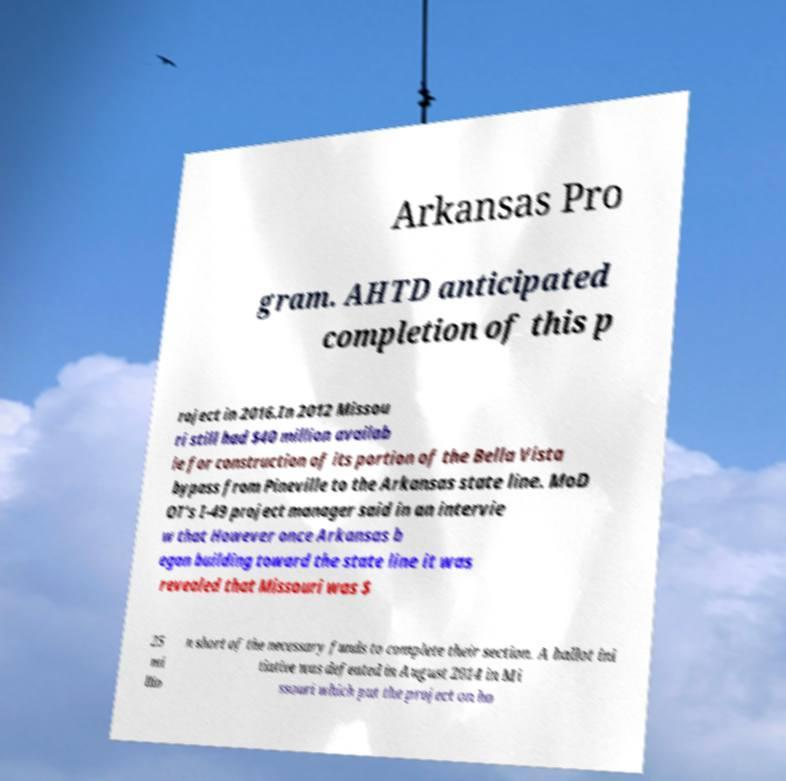There's text embedded in this image that I need extracted. Can you transcribe it verbatim? Arkansas Pro gram. AHTD anticipated completion of this p roject in 2016.In 2012 Missou ri still had $40 million availab le for construction of its portion of the Bella Vista bypass from Pineville to the Arkansas state line. MoD OT's I-49 project manager said in an intervie w that However once Arkansas b egan building toward the state line it was revealed that Missouri was $ 25 mi llio n short of the necessary funds to complete their section. A ballot ini tiative was defeated in August 2014 in Mi ssouri which put the project on ho 